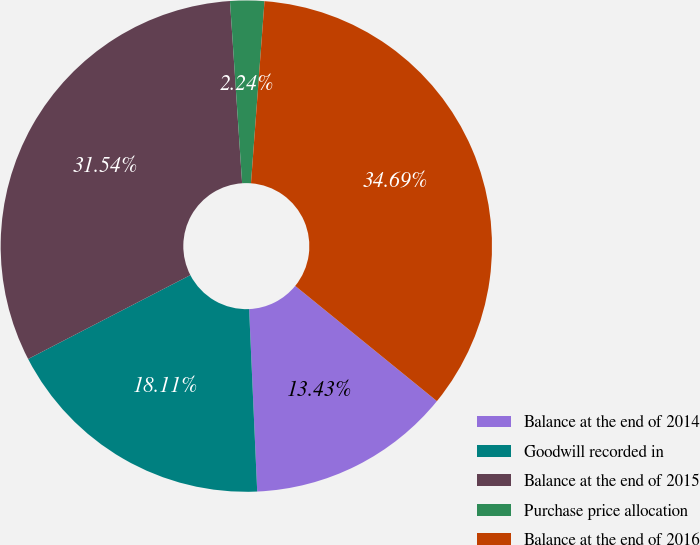Convert chart. <chart><loc_0><loc_0><loc_500><loc_500><pie_chart><fcel>Balance at the end of 2014<fcel>Goodwill recorded in<fcel>Balance at the end of 2015<fcel>Purchase price allocation<fcel>Balance at the end of 2016<nl><fcel>13.43%<fcel>18.11%<fcel>31.54%<fcel>2.24%<fcel>34.69%<nl></chart> 